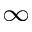<formula> <loc_0><loc_0><loc_500><loc_500>_ { \infty }</formula> 